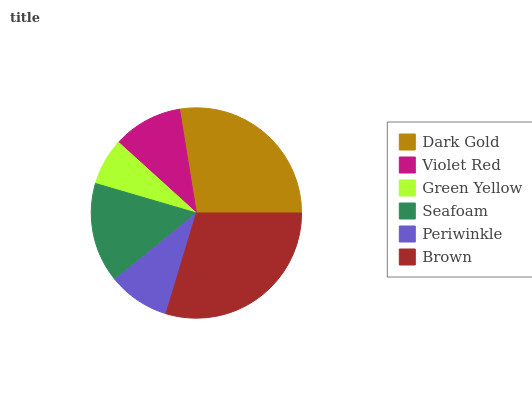Is Green Yellow the minimum?
Answer yes or no. Yes. Is Brown the maximum?
Answer yes or no. Yes. Is Violet Red the minimum?
Answer yes or no. No. Is Violet Red the maximum?
Answer yes or no. No. Is Dark Gold greater than Violet Red?
Answer yes or no. Yes. Is Violet Red less than Dark Gold?
Answer yes or no. Yes. Is Violet Red greater than Dark Gold?
Answer yes or no. No. Is Dark Gold less than Violet Red?
Answer yes or no. No. Is Seafoam the high median?
Answer yes or no. Yes. Is Violet Red the low median?
Answer yes or no. Yes. Is Violet Red the high median?
Answer yes or no. No. Is Brown the low median?
Answer yes or no. No. 